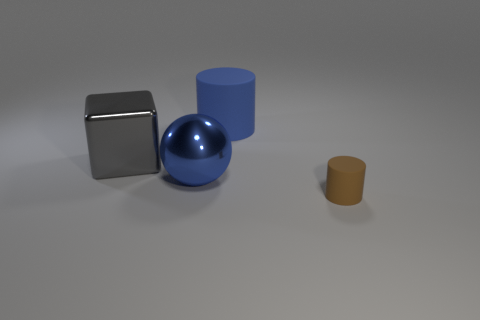Add 2 big cyan objects. How many objects exist? 6 Subtract all small brown matte cylinders. Subtract all yellow rubber balls. How many objects are left? 3 Add 4 blue shiny objects. How many blue shiny objects are left? 5 Add 3 cyan things. How many cyan things exist? 3 Subtract 0 purple cylinders. How many objects are left? 4 Subtract all spheres. How many objects are left? 3 